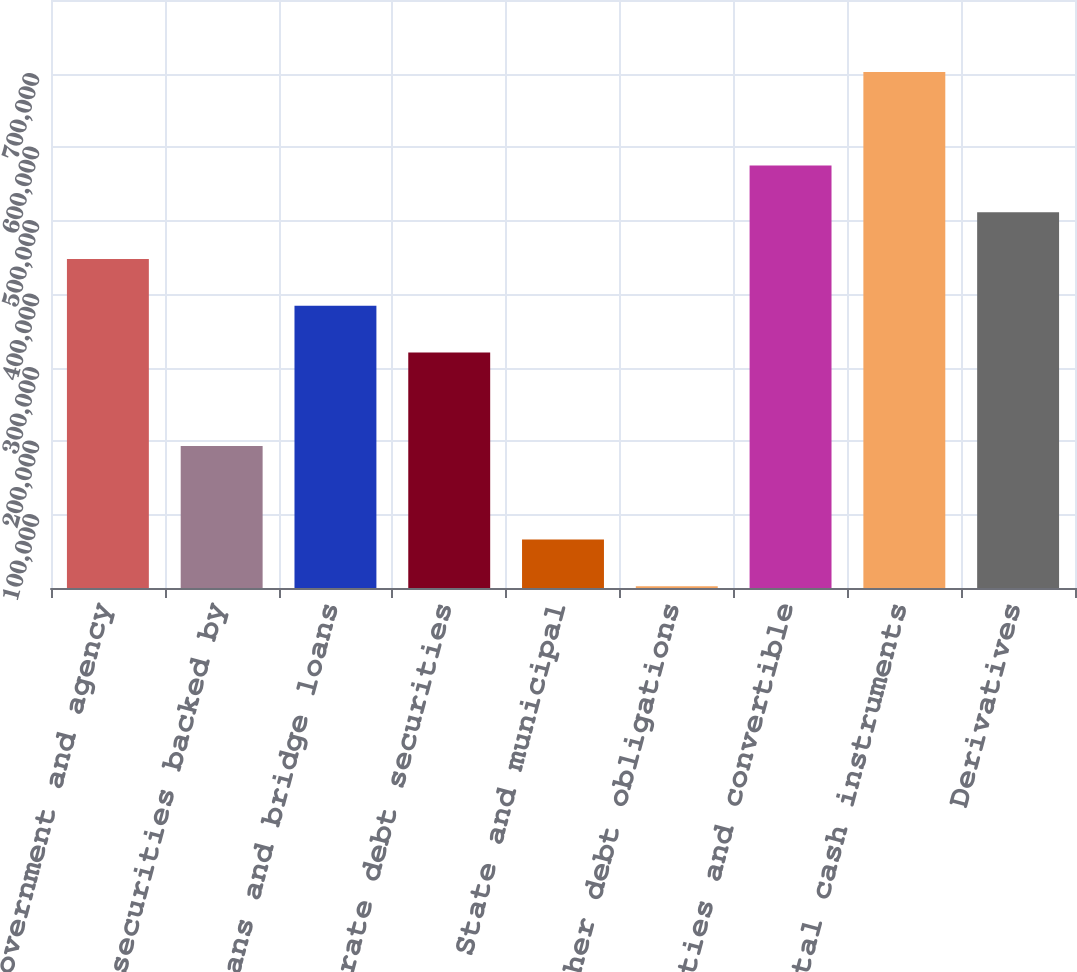Convert chart. <chart><loc_0><loc_0><loc_500><loc_500><bar_chart><fcel>Non-US government and agency<fcel>Loans and securities backed by<fcel>Bank loans and bridge loans<fcel>Corporate debt securities<fcel>State and municipal<fcel>Other debt obligations<fcel>Equities and convertible<fcel>Total cash instruments<fcel>Derivatives<nl><fcel>447634<fcel>193130<fcel>384008<fcel>320382<fcel>65877.2<fcel>2251<fcel>574887<fcel>702139<fcel>511261<nl></chart> 